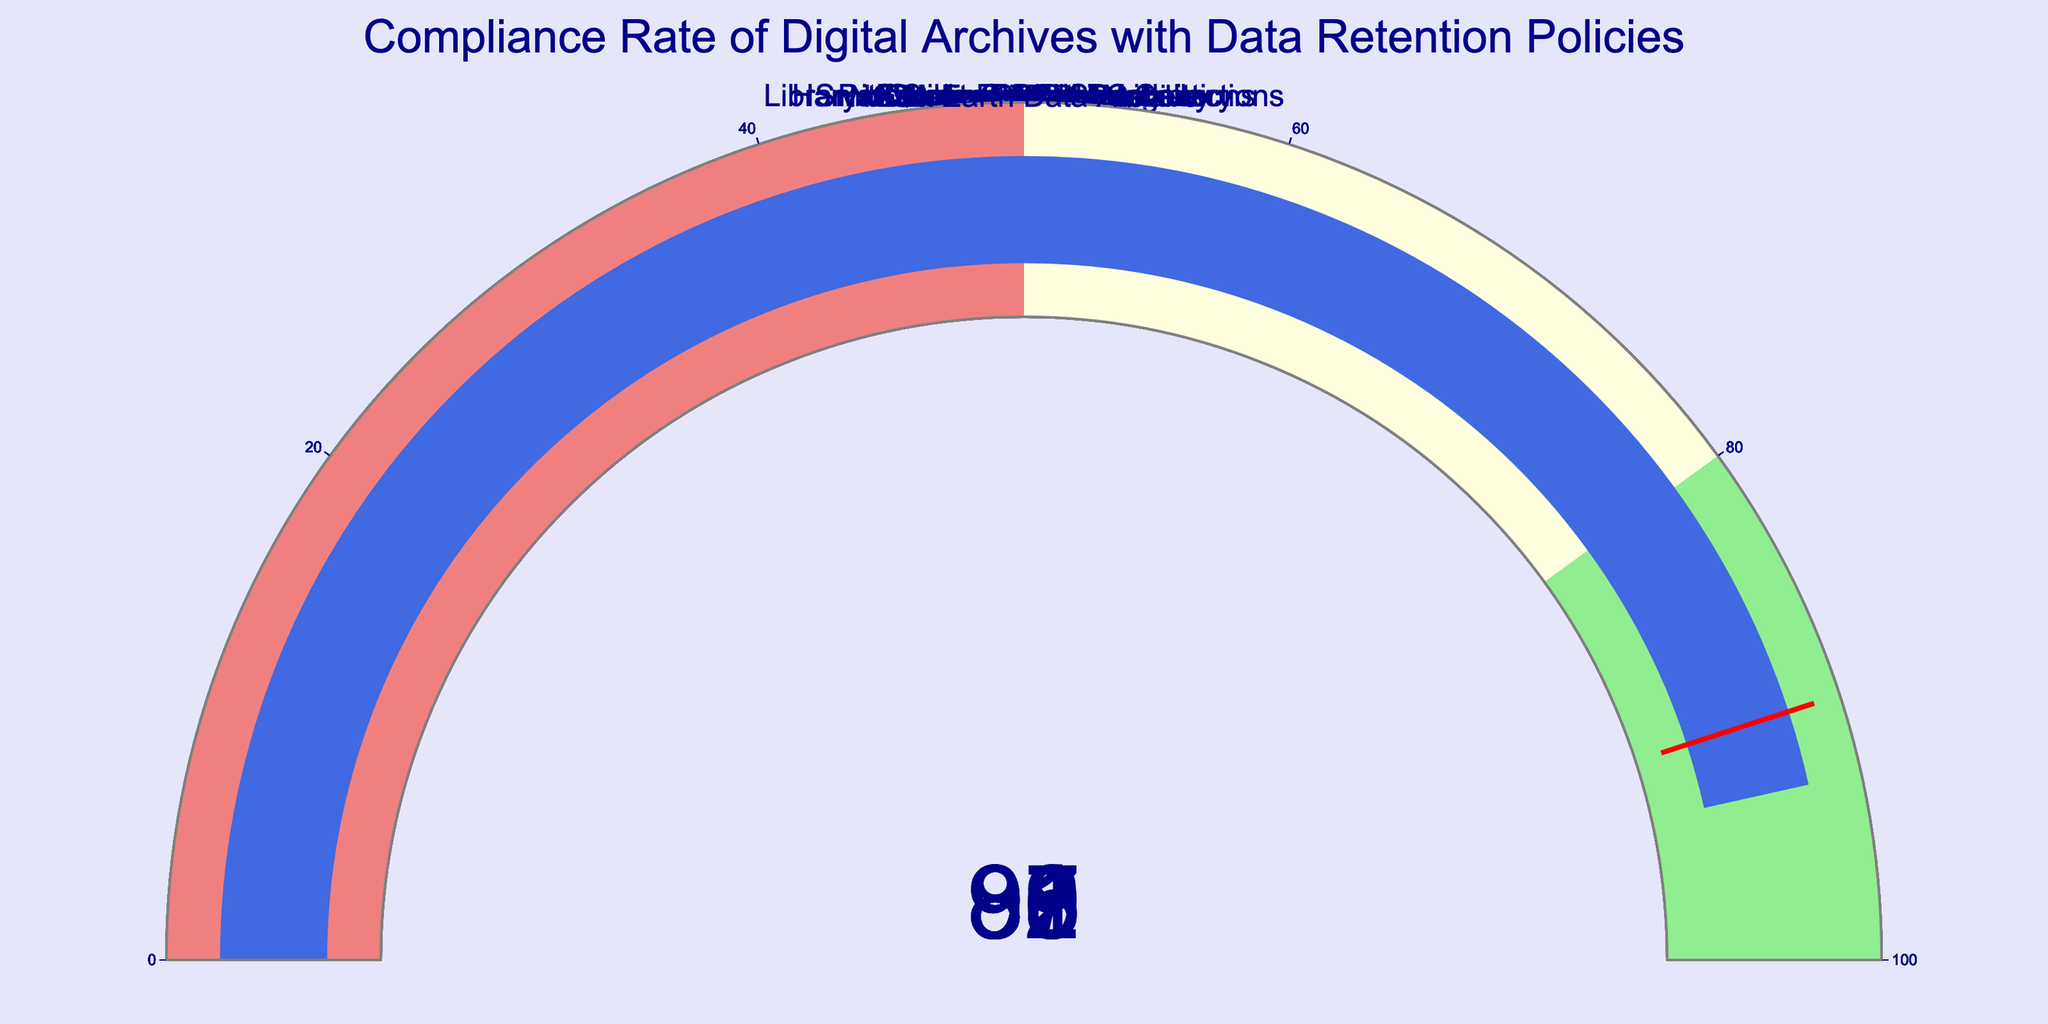What is the highest compliance rate among the digital archives? The highest compliance rate can be identified by looking at the gauges and finding the one with the highest number. The Library of Congress Digital Collections has a compliance rate of 97, which is the highest among the listed archives.
Answer: 97 Which digital archive has the lowest compliance rate? To find the lowest compliance rate, look at the gauges and locate the one with the smallest number. The Internet Archive has a compliance rate of 83, which is the lowest among the listed archives.
Answer: 83 How many digital archives have a compliance rate greater than 90? Count the number of gauges with values greater than 90. There are five such archives: National Archives (92), Harvard Library Digital Collections (95), European Data Portal (91), Library of Congress Digital Collections (97), and NASA Earth Data Archive (93).
Answer: 5 What is the average compliance rate of the Smithsonian Digital Repository, Google Cloud Storage, and ProQuest Research Library? Calculate the average by adding their compliance rates and dividing by three. The rates are 88, 87, and 86, respectively. The sum is 88 + 87 + 86 = 261. The average is 261 / 3 = 87.
Answer: 87 Which digital archive has a compliance rate closest to 90? To determine this, find the archive whose compliance rate is numerically closest to 90. European Data Portal has a compliance rate of 91, which is closest to 90.
Answer: European Data Portal Are there more digital archives with compliance rates above or below 90? Compare the number of gauges with values above 90 to the number with values below 90. There are five archives above 90 and five below 90, so the numbers are equal.
Answer: Equal Which digital archives fall within the compliance range of 85 to 90? Identify the gauges with values between 85 and 90. These archives are Smithsonian Digital Repository (88), European Data Portal (89), ProQuest Research Library (86), and JSTOR (89).
Answer: Smithsonian Digital Repository, JSTOR, ProQuest Research Library, Google Cloud Storage Calculate the difference between the highest and lowest compliance rates. Identify the highest compliance rate (97) and the lowest compliance rate (83), then subtract the lowest from the highest. The difference is 97 - 83 = 14.
Answer: 14 What is the total number of data points represented in the figure? Count all the gauges in the figure. There are 10 digital archives listed, so there are 10 data points.
Answer: 10 In which compliance range (0-50, 51-80, 81-100) do most digital archives fall? Look at the ranges displayed by the colors on the gauges: lightcoral for 0-50, lightyellow for 51-80, and lightgreen for 81-100. Most of the archives (10 out of 10) fall within the 81-100 range.
Answer: 81-100 